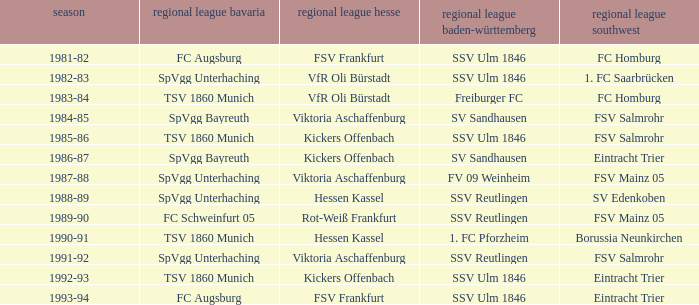Which oberliga baden-württemberg has a season of 1991-92? SSV Reutlingen. 